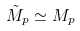Convert formula to latex. <formula><loc_0><loc_0><loc_500><loc_500>\tilde { M } _ { p } \simeq M _ { p }</formula> 